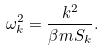<formula> <loc_0><loc_0><loc_500><loc_500>\omega ^ { 2 } _ { k } = \frac { k ^ { 2 } } { \beta m S _ { k } } .</formula> 